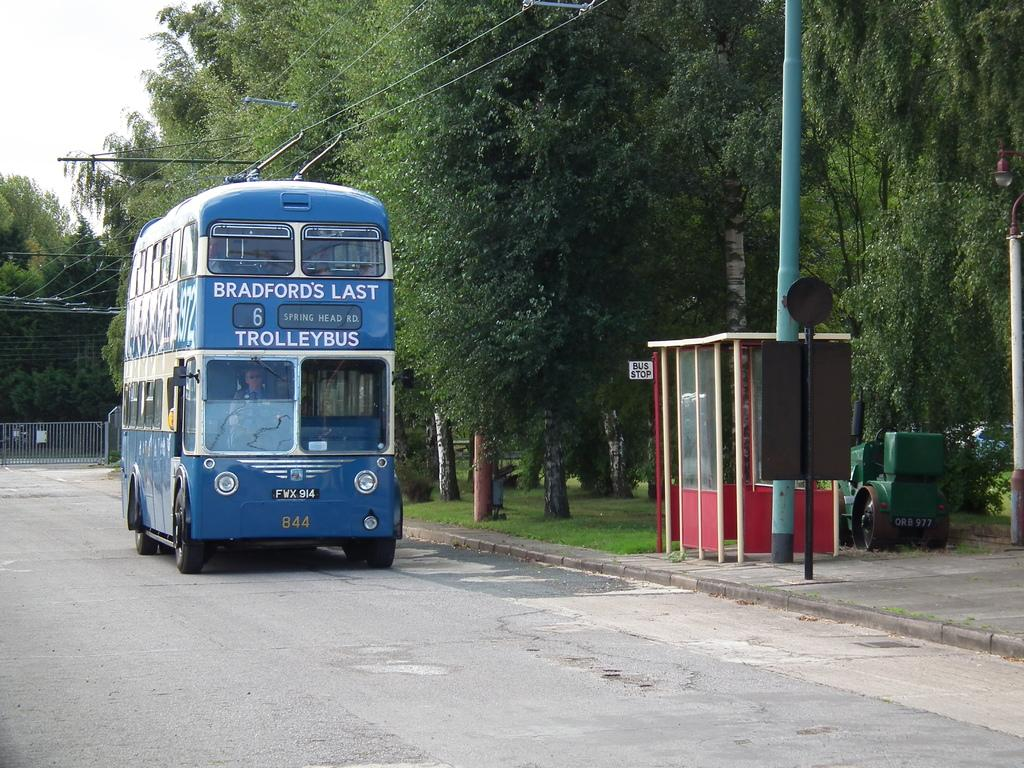Provide a one-sentence caption for the provided image. Blue double decker bus which says Trolleybus on it. 